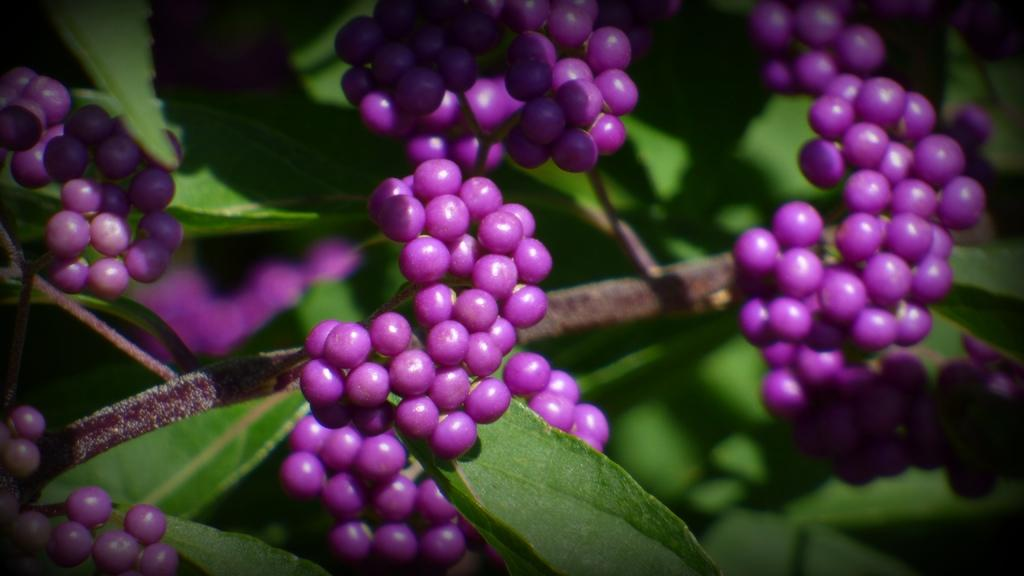What type of living organisms can be seen on the tree in the image? There are fruits on a tree in the image. What type of bead can be seen hanging from the tree in the image? There is no bead present on the tree in the image. 